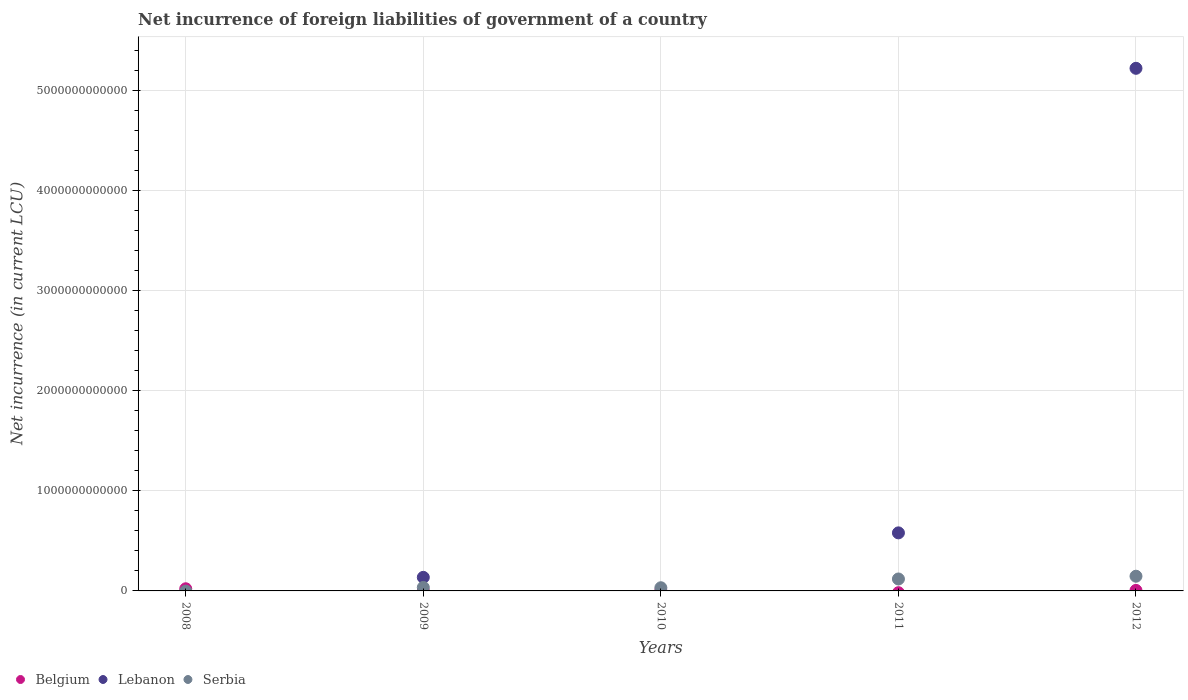How many different coloured dotlines are there?
Your response must be concise. 3. Is the number of dotlines equal to the number of legend labels?
Make the answer very short. No. What is the net incurrence of foreign liabilities in Lebanon in 2009?
Offer a very short reply. 1.35e+11. Across all years, what is the maximum net incurrence of foreign liabilities in Serbia?
Your answer should be very brief. 1.47e+11. Across all years, what is the minimum net incurrence of foreign liabilities in Lebanon?
Make the answer very short. 0. What is the total net incurrence of foreign liabilities in Lebanon in the graph?
Keep it short and to the point. 5.94e+12. What is the difference between the net incurrence of foreign liabilities in Belgium in 2008 and that in 2010?
Offer a very short reply. 1.80e+1. What is the difference between the net incurrence of foreign liabilities in Belgium in 2010 and the net incurrence of foreign liabilities in Serbia in 2009?
Provide a short and direct response. -3.13e+1. What is the average net incurrence of foreign liabilities in Belgium per year?
Your answer should be very brief. 6.07e+09. In the year 2010, what is the difference between the net incurrence of foreign liabilities in Belgium and net incurrence of foreign liabilities in Serbia?
Offer a terse response. -2.82e+1. What is the ratio of the net incurrence of foreign liabilities in Serbia in 2011 to that in 2012?
Offer a terse response. 0.81. Is the net incurrence of foreign liabilities in Serbia in 2009 less than that in 2012?
Give a very brief answer. Yes. What is the difference between the highest and the second highest net incurrence of foreign liabilities in Serbia?
Your answer should be compact. 2.75e+1. What is the difference between the highest and the lowest net incurrence of foreign liabilities in Serbia?
Keep it short and to the point. 1.47e+11. In how many years, is the net incurrence of foreign liabilities in Belgium greater than the average net incurrence of foreign liabilities in Belgium taken over all years?
Ensure brevity in your answer.  1. Is it the case that in every year, the sum of the net incurrence of foreign liabilities in Belgium and net incurrence of foreign liabilities in Lebanon  is greater than the net incurrence of foreign liabilities in Serbia?
Provide a short and direct response. No. Does the net incurrence of foreign liabilities in Lebanon monotonically increase over the years?
Offer a very short reply. No. Is the net incurrence of foreign liabilities in Belgium strictly greater than the net incurrence of foreign liabilities in Serbia over the years?
Offer a terse response. No. How many years are there in the graph?
Your response must be concise. 5. What is the difference between two consecutive major ticks on the Y-axis?
Your response must be concise. 1.00e+12. Does the graph contain any zero values?
Your response must be concise. Yes. Does the graph contain grids?
Ensure brevity in your answer.  Yes. Where does the legend appear in the graph?
Give a very brief answer. Bottom left. How many legend labels are there?
Your answer should be compact. 3. How are the legend labels stacked?
Your answer should be compact. Horizontal. What is the title of the graph?
Ensure brevity in your answer.  Net incurrence of foreign liabilities of government of a country. Does "Colombia" appear as one of the legend labels in the graph?
Your answer should be compact. No. What is the label or title of the Y-axis?
Make the answer very short. Net incurrence (in current LCU). What is the Net incurrence (in current LCU) of Belgium in 2008?
Your answer should be very brief. 2.15e+1. What is the Net incurrence (in current LCU) of Serbia in 2008?
Give a very brief answer. 0. What is the Net incurrence (in current LCU) in Belgium in 2009?
Provide a succinct answer. 0. What is the Net incurrence (in current LCU) of Lebanon in 2009?
Your answer should be very brief. 1.35e+11. What is the Net incurrence (in current LCU) of Serbia in 2009?
Provide a succinct answer. 3.48e+1. What is the Net incurrence (in current LCU) in Belgium in 2010?
Give a very brief answer. 3.50e+09. What is the Net incurrence (in current LCU) in Serbia in 2010?
Your answer should be very brief. 3.17e+1. What is the Net incurrence (in current LCU) of Lebanon in 2011?
Your answer should be compact. 5.80e+11. What is the Net incurrence (in current LCU) of Serbia in 2011?
Your answer should be compact. 1.19e+11. What is the Net incurrence (in current LCU) of Belgium in 2012?
Offer a very short reply. 5.30e+09. What is the Net incurrence (in current LCU) in Lebanon in 2012?
Your answer should be very brief. 5.22e+12. What is the Net incurrence (in current LCU) of Serbia in 2012?
Your answer should be compact. 1.47e+11. Across all years, what is the maximum Net incurrence (in current LCU) of Belgium?
Keep it short and to the point. 2.15e+1. Across all years, what is the maximum Net incurrence (in current LCU) in Lebanon?
Provide a short and direct response. 5.22e+12. Across all years, what is the maximum Net incurrence (in current LCU) of Serbia?
Ensure brevity in your answer.  1.47e+11. Across all years, what is the minimum Net incurrence (in current LCU) of Lebanon?
Provide a succinct answer. 0. What is the total Net incurrence (in current LCU) of Belgium in the graph?
Provide a succinct answer. 3.03e+1. What is the total Net incurrence (in current LCU) of Lebanon in the graph?
Make the answer very short. 5.94e+12. What is the total Net incurrence (in current LCU) of Serbia in the graph?
Your answer should be compact. 3.33e+11. What is the difference between the Net incurrence (in current LCU) in Belgium in 2008 and that in 2010?
Your answer should be compact. 1.80e+1. What is the difference between the Net incurrence (in current LCU) of Belgium in 2008 and that in 2012?
Make the answer very short. 1.62e+1. What is the difference between the Net incurrence (in current LCU) of Serbia in 2009 and that in 2010?
Provide a short and direct response. 3.08e+09. What is the difference between the Net incurrence (in current LCU) in Lebanon in 2009 and that in 2011?
Your answer should be compact. -4.45e+11. What is the difference between the Net incurrence (in current LCU) of Serbia in 2009 and that in 2011?
Your response must be concise. -8.45e+1. What is the difference between the Net incurrence (in current LCU) of Lebanon in 2009 and that in 2012?
Your answer should be very brief. -5.09e+12. What is the difference between the Net incurrence (in current LCU) in Serbia in 2009 and that in 2012?
Your answer should be compact. -1.12e+11. What is the difference between the Net incurrence (in current LCU) of Serbia in 2010 and that in 2011?
Ensure brevity in your answer.  -8.76e+1. What is the difference between the Net incurrence (in current LCU) of Belgium in 2010 and that in 2012?
Ensure brevity in your answer.  -1.80e+09. What is the difference between the Net incurrence (in current LCU) of Serbia in 2010 and that in 2012?
Your response must be concise. -1.15e+11. What is the difference between the Net incurrence (in current LCU) of Lebanon in 2011 and that in 2012?
Your answer should be very brief. -4.64e+12. What is the difference between the Net incurrence (in current LCU) of Serbia in 2011 and that in 2012?
Ensure brevity in your answer.  -2.75e+1. What is the difference between the Net incurrence (in current LCU) in Belgium in 2008 and the Net incurrence (in current LCU) in Lebanon in 2009?
Offer a terse response. -1.14e+11. What is the difference between the Net incurrence (in current LCU) of Belgium in 2008 and the Net incurrence (in current LCU) of Serbia in 2009?
Keep it short and to the point. -1.33e+1. What is the difference between the Net incurrence (in current LCU) in Belgium in 2008 and the Net incurrence (in current LCU) in Serbia in 2010?
Your answer should be compact. -1.02e+1. What is the difference between the Net incurrence (in current LCU) in Belgium in 2008 and the Net incurrence (in current LCU) in Lebanon in 2011?
Keep it short and to the point. -5.58e+11. What is the difference between the Net incurrence (in current LCU) in Belgium in 2008 and the Net incurrence (in current LCU) in Serbia in 2011?
Your response must be concise. -9.78e+1. What is the difference between the Net incurrence (in current LCU) in Belgium in 2008 and the Net incurrence (in current LCU) in Lebanon in 2012?
Provide a short and direct response. -5.20e+12. What is the difference between the Net incurrence (in current LCU) of Belgium in 2008 and the Net incurrence (in current LCU) of Serbia in 2012?
Offer a very short reply. -1.25e+11. What is the difference between the Net incurrence (in current LCU) of Lebanon in 2009 and the Net incurrence (in current LCU) of Serbia in 2010?
Provide a short and direct response. 1.04e+11. What is the difference between the Net incurrence (in current LCU) in Lebanon in 2009 and the Net incurrence (in current LCU) in Serbia in 2011?
Keep it short and to the point. 1.61e+1. What is the difference between the Net incurrence (in current LCU) in Lebanon in 2009 and the Net incurrence (in current LCU) in Serbia in 2012?
Your response must be concise. -1.14e+1. What is the difference between the Net incurrence (in current LCU) of Belgium in 2010 and the Net incurrence (in current LCU) of Lebanon in 2011?
Make the answer very short. -5.77e+11. What is the difference between the Net incurrence (in current LCU) of Belgium in 2010 and the Net incurrence (in current LCU) of Serbia in 2011?
Make the answer very short. -1.16e+11. What is the difference between the Net incurrence (in current LCU) of Belgium in 2010 and the Net incurrence (in current LCU) of Lebanon in 2012?
Your answer should be compact. -5.22e+12. What is the difference between the Net incurrence (in current LCU) of Belgium in 2010 and the Net incurrence (in current LCU) of Serbia in 2012?
Your answer should be compact. -1.43e+11. What is the difference between the Net incurrence (in current LCU) of Lebanon in 2011 and the Net incurrence (in current LCU) of Serbia in 2012?
Provide a succinct answer. 4.33e+11. What is the average Net incurrence (in current LCU) of Belgium per year?
Ensure brevity in your answer.  6.07e+09. What is the average Net incurrence (in current LCU) in Lebanon per year?
Make the answer very short. 1.19e+12. What is the average Net incurrence (in current LCU) of Serbia per year?
Provide a succinct answer. 6.66e+1. In the year 2009, what is the difference between the Net incurrence (in current LCU) of Lebanon and Net incurrence (in current LCU) of Serbia?
Offer a very short reply. 1.01e+11. In the year 2010, what is the difference between the Net incurrence (in current LCU) in Belgium and Net incurrence (in current LCU) in Serbia?
Provide a short and direct response. -2.82e+1. In the year 2011, what is the difference between the Net incurrence (in current LCU) of Lebanon and Net incurrence (in current LCU) of Serbia?
Offer a terse response. 4.61e+11. In the year 2012, what is the difference between the Net incurrence (in current LCU) of Belgium and Net incurrence (in current LCU) of Lebanon?
Your answer should be compact. -5.22e+12. In the year 2012, what is the difference between the Net incurrence (in current LCU) of Belgium and Net incurrence (in current LCU) of Serbia?
Your answer should be very brief. -1.42e+11. In the year 2012, what is the difference between the Net incurrence (in current LCU) of Lebanon and Net incurrence (in current LCU) of Serbia?
Keep it short and to the point. 5.07e+12. What is the ratio of the Net incurrence (in current LCU) of Belgium in 2008 to that in 2010?
Ensure brevity in your answer.  6.16. What is the ratio of the Net incurrence (in current LCU) of Belgium in 2008 to that in 2012?
Provide a succinct answer. 4.07. What is the ratio of the Net incurrence (in current LCU) in Serbia in 2009 to that in 2010?
Your answer should be compact. 1.1. What is the ratio of the Net incurrence (in current LCU) in Lebanon in 2009 to that in 2011?
Your answer should be compact. 0.23. What is the ratio of the Net incurrence (in current LCU) of Serbia in 2009 to that in 2011?
Provide a succinct answer. 0.29. What is the ratio of the Net incurrence (in current LCU) of Lebanon in 2009 to that in 2012?
Your answer should be very brief. 0.03. What is the ratio of the Net incurrence (in current LCU) in Serbia in 2009 to that in 2012?
Make the answer very short. 0.24. What is the ratio of the Net incurrence (in current LCU) in Serbia in 2010 to that in 2011?
Offer a very short reply. 0.27. What is the ratio of the Net incurrence (in current LCU) in Belgium in 2010 to that in 2012?
Ensure brevity in your answer.  0.66. What is the ratio of the Net incurrence (in current LCU) of Serbia in 2010 to that in 2012?
Your response must be concise. 0.22. What is the ratio of the Net incurrence (in current LCU) in Lebanon in 2011 to that in 2012?
Offer a terse response. 0.11. What is the ratio of the Net incurrence (in current LCU) of Serbia in 2011 to that in 2012?
Keep it short and to the point. 0.81. What is the difference between the highest and the second highest Net incurrence (in current LCU) in Belgium?
Your answer should be compact. 1.62e+1. What is the difference between the highest and the second highest Net incurrence (in current LCU) in Lebanon?
Your answer should be compact. 4.64e+12. What is the difference between the highest and the second highest Net incurrence (in current LCU) in Serbia?
Give a very brief answer. 2.75e+1. What is the difference between the highest and the lowest Net incurrence (in current LCU) in Belgium?
Provide a short and direct response. 2.15e+1. What is the difference between the highest and the lowest Net incurrence (in current LCU) in Lebanon?
Provide a succinct answer. 5.22e+12. What is the difference between the highest and the lowest Net incurrence (in current LCU) in Serbia?
Provide a succinct answer. 1.47e+11. 